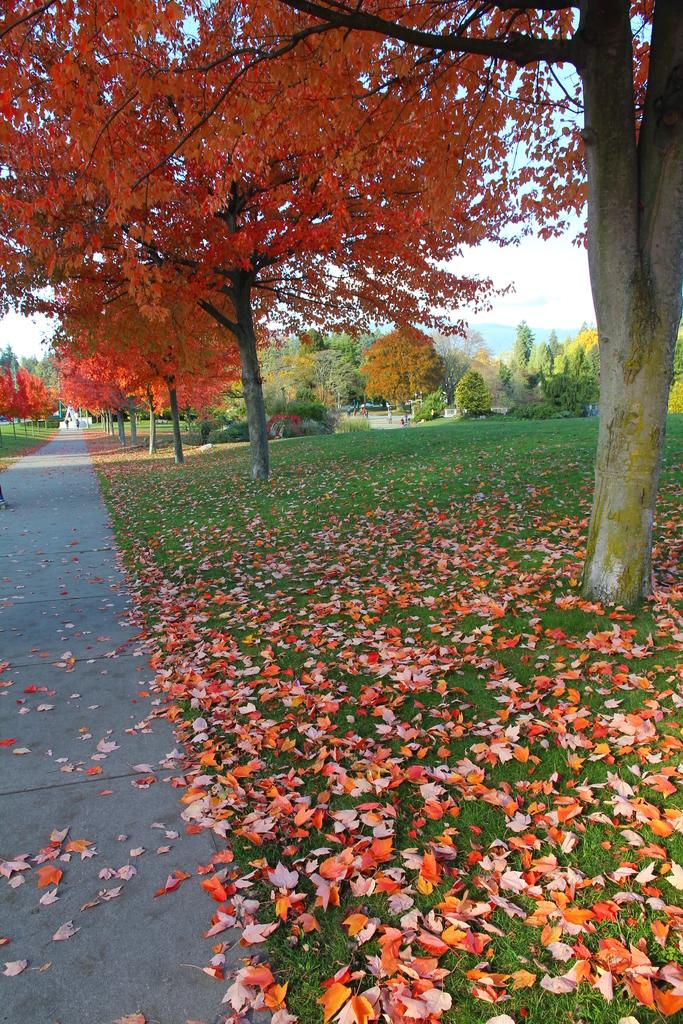What type of vegetation can be seen on either side of the road in the image? There are trees and grass on either side of the road in the image. What can be seen in the background of the image? The sky is visible in the background of the image. Are there any signs of the changing seasons in the image? Yes, dried leaves are present in the image, which may indicate that it is autumn. How many screws can be seen holding the sand in place in the image? There is no sand or screws present in the image. 